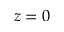<formula> <loc_0><loc_0><loc_500><loc_500>z = 0</formula> 